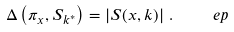Convert formula to latex. <formula><loc_0><loc_0><loc_500><loc_500>\Delta \left ( \pi _ { x } , S _ { k ^ { \ast } } \right ) = \left | S ( x , k ) \right | \, . \quad \ e p</formula> 